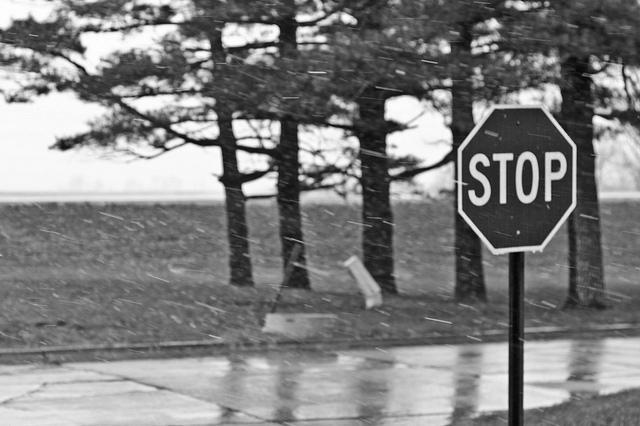How many baby elephants are there?
Give a very brief answer. 0. 